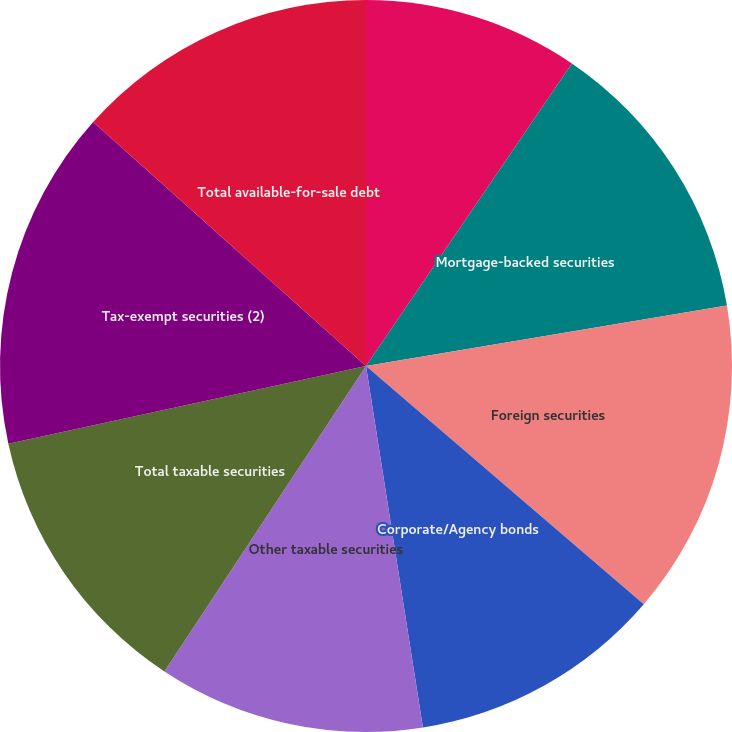Convert chart to OTSL. <chart><loc_0><loc_0><loc_500><loc_500><pie_chart><fcel>US Treasury securities and<fcel>Mortgage-backed securities<fcel>Foreign securities<fcel>Corporate/Agency bonds<fcel>Other taxable securities<fcel>Total taxable securities<fcel>Tax-exempt securities (2)<fcel>Total available-for-sale debt<nl><fcel>9.51%<fcel>12.85%<fcel>13.93%<fcel>11.23%<fcel>11.77%<fcel>12.31%<fcel>15.02%<fcel>13.39%<nl></chart> 